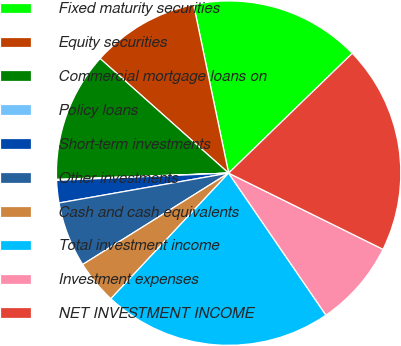Convert chart to OTSL. <chart><loc_0><loc_0><loc_500><loc_500><pie_chart><fcel>Fixed maturity securities<fcel>Equity securities<fcel>Commercial mortgage loans on<fcel>Policy loans<fcel>Short-term investments<fcel>Other investments<fcel>Cash and cash equivalents<fcel>Total investment income<fcel>Investment expenses<fcel>NET INVESTMENT INCOME<nl><fcel>16.02%<fcel>10.15%<fcel>12.17%<fcel>0.09%<fcel>2.1%<fcel>6.13%<fcel>4.11%<fcel>21.55%<fcel>8.14%<fcel>19.54%<nl></chart> 